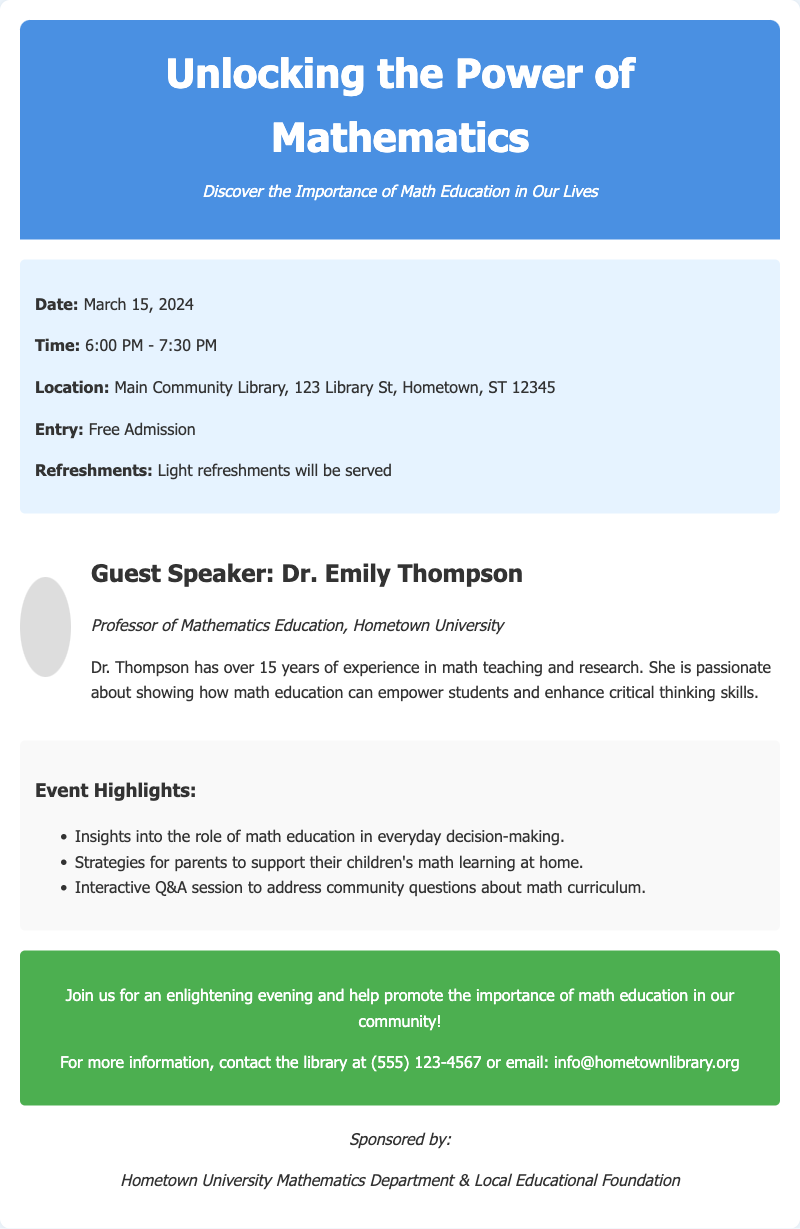What is the date of the event? The date is stated in the event details section of the document.
Answer: March 15, 2024 What time does the event start? The start time is indicated in the event details section of the document.
Answer: 6:00 PM Who is the guest speaker? The guest speaker's name is mentioned in the speaker section of the document.
Answer: Dr. Emily Thompson What is the location of the event? The location is provided in the event details section of the document.
Answer: Main Community Library, 123 Library St, Hometown, ST 12345 What type of refreshments will be served? The type of refreshments is specified in the event details section of the document.
Answer: Light refreshments What is one highlight of the event? Highlights are listed in the highlights section; any item can be used as an answer.
Answer: Interactive Q&A session to address community questions about math curriculum How long is the event scheduled to last? The duration can be inferred from the start and end times mentioned in the document.
Answer: 1.5 hours What role does Dr. Emily Thompson hold? Dr. Thompson's role is stated in the speaker section of the document.
Answer: Professor of Mathematics Education What is the cost of admission? The admission cost is noted in the event details.
Answer: Free Admission 